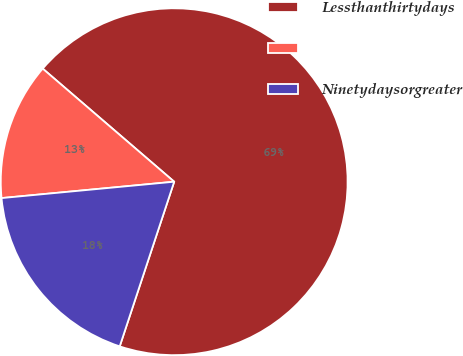<chart> <loc_0><loc_0><loc_500><loc_500><pie_chart><fcel>Lessthanthirtydays<fcel>Unnamed: 1<fcel>Ninetydaysorgreater<nl><fcel>68.78%<fcel>12.81%<fcel>18.41%<nl></chart> 